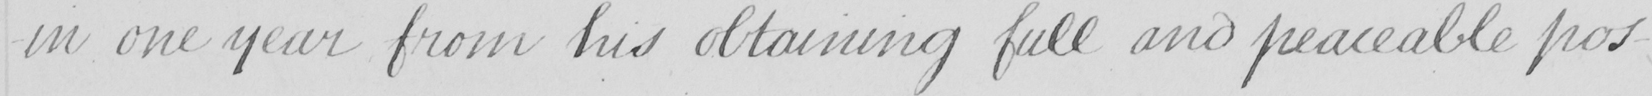Please transcribe the handwritten text in this image. in one year from his obtaining full and peaceable pos- 